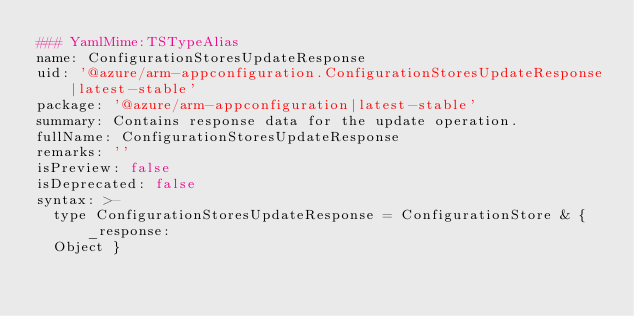<code> <loc_0><loc_0><loc_500><loc_500><_YAML_>### YamlMime:TSTypeAlias
name: ConfigurationStoresUpdateResponse
uid: '@azure/arm-appconfiguration.ConfigurationStoresUpdateResponse|latest-stable'
package: '@azure/arm-appconfiguration|latest-stable'
summary: Contains response data for the update operation.
fullName: ConfigurationStoresUpdateResponse
remarks: ''
isPreview: false
isDeprecated: false
syntax: >-
  type ConfigurationStoresUpdateResponse = ConfigurationStore & { _response:
  Object }
</code> 